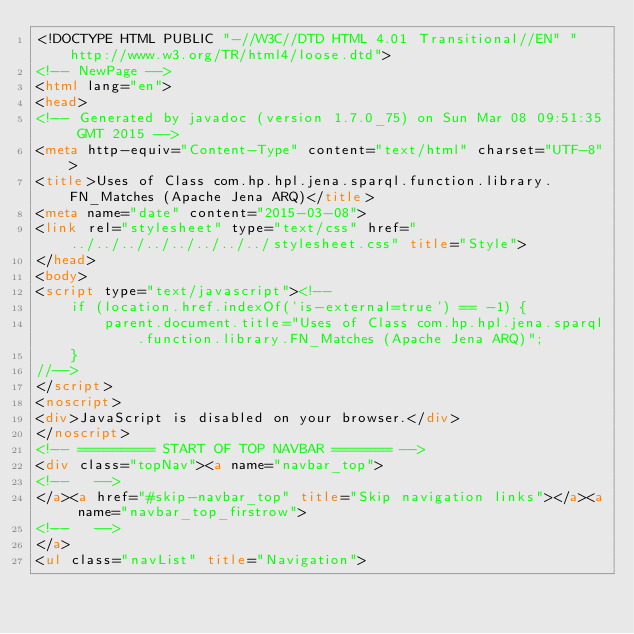<code> <loc_0><loc_0><loc_500><loc_500><_HTML_><!DOCTYPE HTML PUBLIC "-//W3C//DTD HTML 4.01 Transitional//EN" "http://www.w3.org/TR/html4/loose.dtd">
<!-- NewPage -->
<html lang="en">
<head>
<!-- Generated by javadoc (version 1.7.0_75) on Sun Mar 08 09:51:35 GMT 2015 -->
<meta http-equiv="Content-Type" content="text/html" charset="UTF-8">
<title>Uses of Class com.hp.hpl.jena.sparql.function.library.FN_Matches (Apache Jena ARQ)</title>
<meta name="date" content="2015-03-08">
<link rel="stylesheet" type="text/css" href="../../../../../../../../stylesheet.css" title="Style">
</head>
<body>
<script type="text/javascript"><!--
    if (location.href.indexOf('is-external=true') == -1) {
        parent.document.title="Uses of Class com.hp.hpl.jena.sparql.function.library.FN_Matches (Apache Jena ARQ)";
    }
//-->
</script>
<noscript>
<div>JavaScript is disabled on your browser.</div>
</noscript>
<!-- ========= START OF TOP NAVBAR ======= -->
<div class="topNav"><a name="navbar_top">
<!--   -->
</a><a href="#skip-navbar_top" title="Skip navigation links"></a><a name="navbar_top_firstrow">
<!--   -->
</a>
<ul class="navList" title="Navigation"></code> 